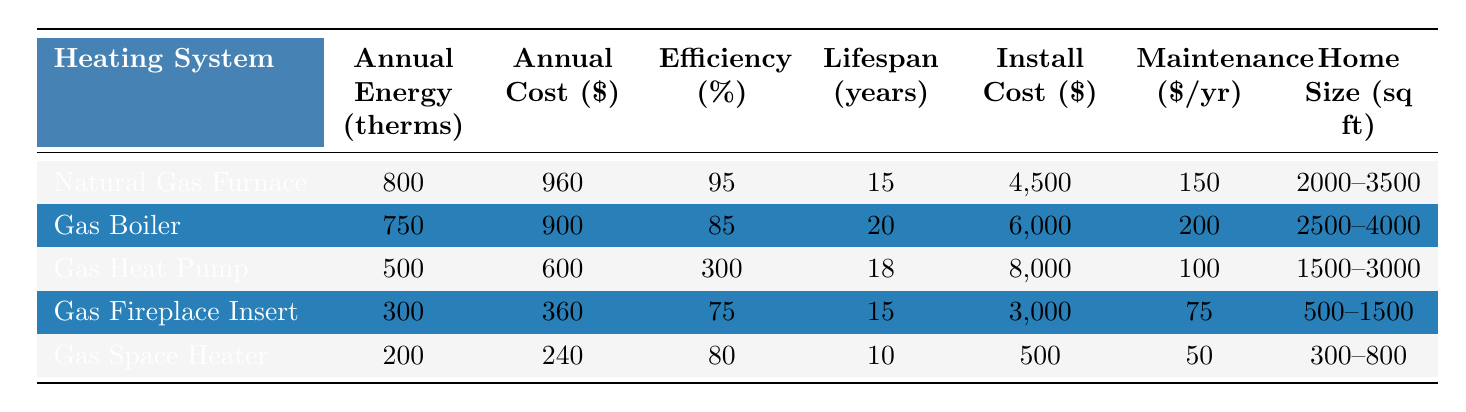What is the annual energy consumption for a Gas Boiler? The table directly lists the annual energy consumption for the Gas Boiler, which is 750 therms.
Answer: 750 therms Which heating system has the lowest annual cost? By looking through the annual cost column, the Gas Space Heater has the lowest annual cost at $240.
Answer: Gas Space Heater What is the average efficiency of all heating systems? To find the average efficiency, add up all the efficiencies: (95 + 85 + 300 + 75 + 80) = 635. Dividing by the number of systems (5) gives an average efficiency of 127.
Answer: 127% How many years does a Gas Heat Pump typically last? The typical lifespan of a Gas Heat Pump is listed in the table as 18 years.
Answer: 18 years Which heating system type is suitable for the smallest home size? Looking at the home size suitability column, the Gas Space Heater is suitable for homes sized 300-800 sq ft, which is the smallest range.
Answer: Gas Space Heater What is the total installation cost for a Natural Gas Furnace and a Gas Boiler? The installation cost for a Natural Gas Furnace is $4,500 and for a Gas Boiler is $6,000. Adding them gives $4,500 + $6,000 = $10,500.
Answer: $10,500 Is the annual maintenance cost for a Gas Heat Pump higher than that of a Gas Fireplace Insert? The annual maintenance costs are $100 for the Gas Heat Pump and $75 for the Gas Fireplace Insert. Since $100 is greater than $75, the answer is yes.
Answer: Yes What is the difference in annual energy consumption between a Natural Gas Furnace and a Gas Space Heater? The Natural Gas Furnace consumes 800 therms and the Gas Space Heater consumes 200 therms. The difference is 800 - 200 = 600 therms.
Answer: 600 therms Which heating system has an efficiency percentage greater than 90%? The systems with efficiencies greater than 90% are the Natural Gas Furnace (95%) and the Gas Heat Pump (300%).
Answer: Natural Gas Furnace, Gas Heat Pump What is the average annual maintenance cost across all systems? The annual maintenance costs are $150, $200, $100, $75, and $50. Adding these gives $150 + $200 + $100 + $75 + $50 = $575. Dividing by five results in an average of $115.
Answer: $115 